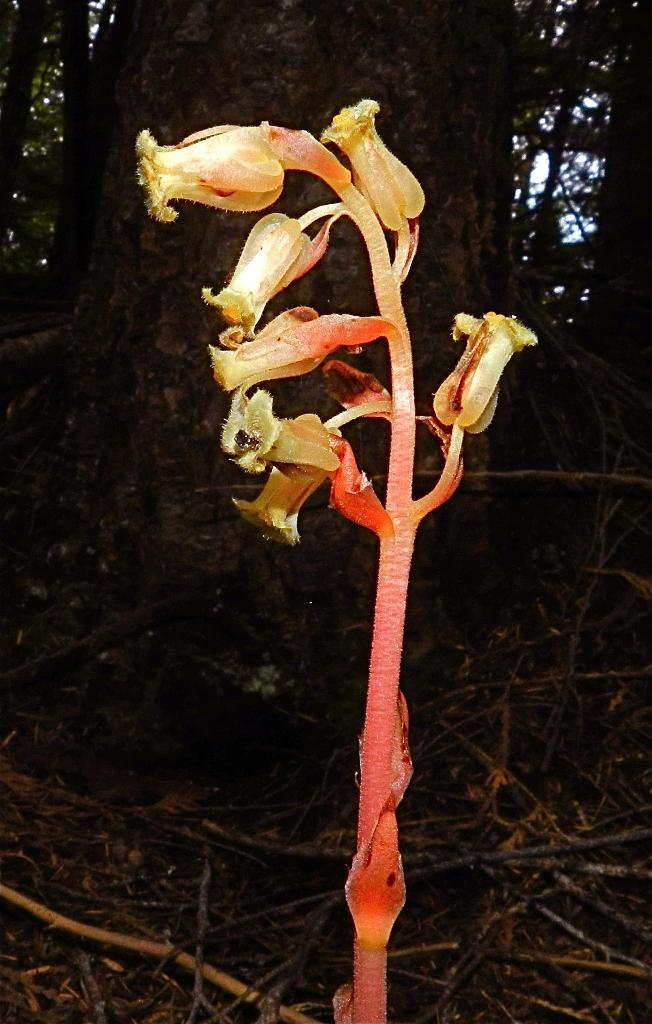What type of plants can be seen in the image? There are flowers in the image. What other objects are present in the image? There are sticks in the image. What can be seen in the background of the image? There are trees in the background of the image. What type of animal is sitting on the basket in the image? There is no basket or animal present in the image. 